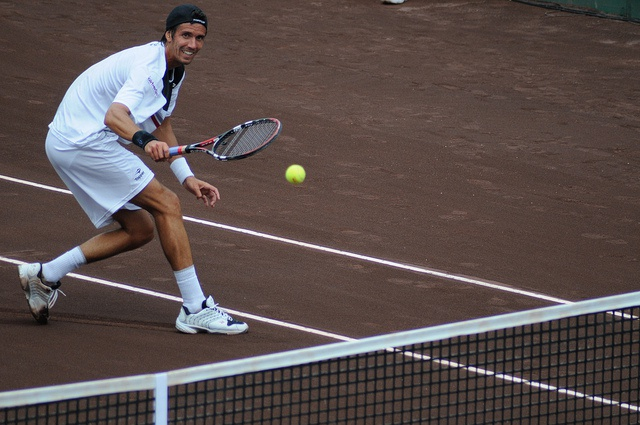Describe the objects in this image and their specific colors. I can see people in black, lightblue, and darkgray tones, tennis racket in black and gray tones, and sports ball in black, khaki, lightgreen, and olive tones in this image. 